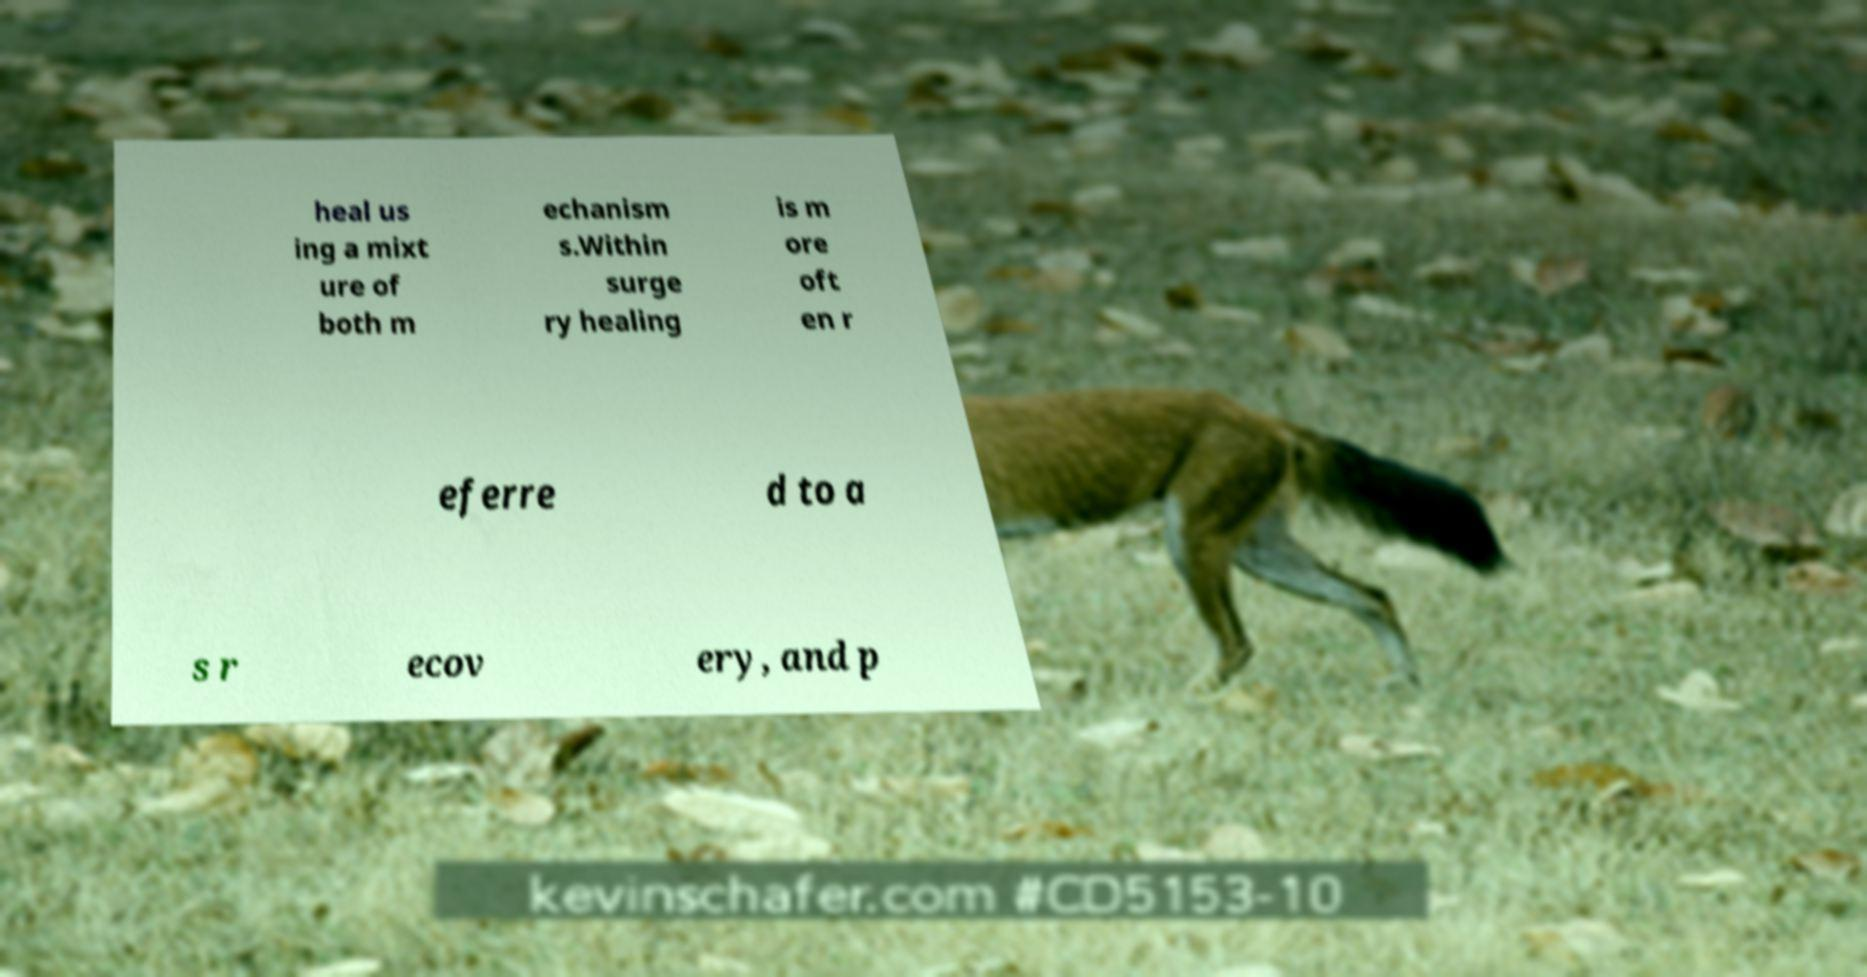Could you assist in decoding the text presented in this image and type it out clearly? heal us ing a mixt ure of both m echanism s.Within surge ry healing is m ore oft en r eferre d to a s r ecov ery, and p 